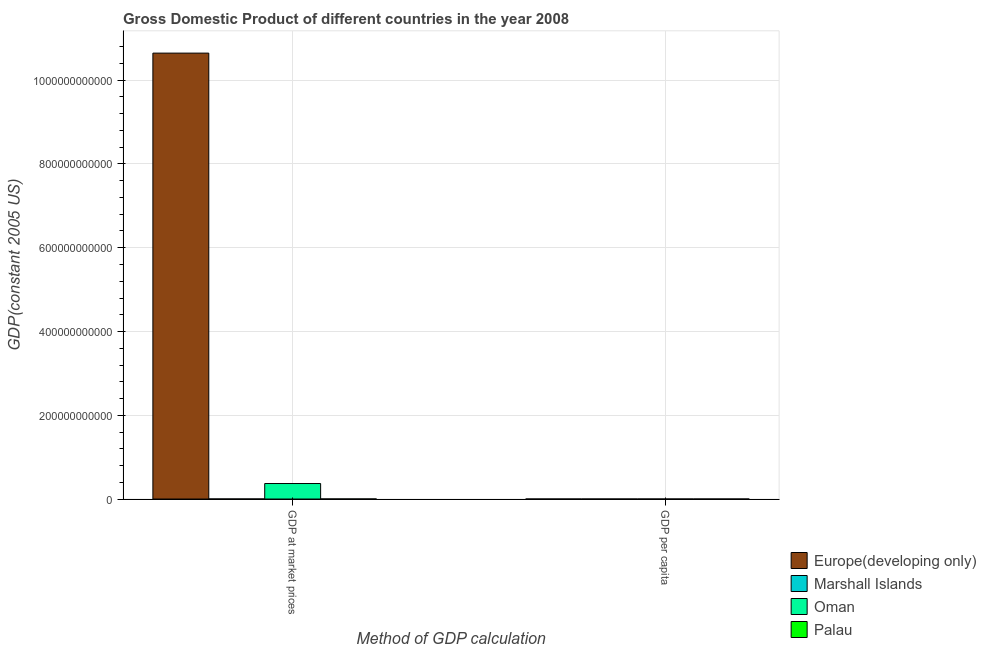How many groups of bars are there?
Provide a short and direct response. 2. Are the number of bars on each tick of the X-axis equal?
Your response must be concise. Yes. How many bars are there on the 1st tick from the left?
Provide a succinct answer. 4. How many bars are there on the 2nd tick from the right?
Your answer should be compact. 4. What is the label of the 1st group of bars from the left?
Provide a short and direct response. GDP at market prices. What is the gdp at market prices in Europe(developing only)?
Offer a terse response. 1.06e+12. Across all countries, what is the maximum gdp per capita?
Your answer should be compact. 1.40e+04. Across all countries, what is the minimum gdp per capita?
Your answer should be very brief. 2736.21. In which country was the gdp at market prices maximum?
Ensure brevity in your answer.  Europe(developing only). In which country was the gdp at market prices minimum?
Provide a short and direct response. Marshall Islands. What is the total gdp at market prices in the graph?
Give a very brief answer. 1.10e+12. What is the difference between the gdp per capita in Palau and that in Oman?
Your answer should be compact. -4999.17. What is the difference between the gdp per capita in Palau and the gdp at market prices in Oman?
Offer a terse response. -3.70e+1. What is the average gdp at market prices per country?
Provide a short and direct response. 2.76e+11. What is the difference between the gdp per capita and gdp at market prices in Palau?
Ensure brevity in your answer.  -1.81e+08. In how many countries, is the gdp per capita greater than 640000000000 US$?
Your answer should be compact. 0. What is the ratio of the gdp per capita in Europe(developing only) to that in Palau?
Offer a very short reply. 0.47. What does the 4th bar from the left in GDP at market prices represents?
Offer a very short reply. Palau. What does the 4th bar from the right in GDP per capita represents?
Make the answer very short. Europe(developing only). How many bars are there?
Give a very brief answer. 8. What is the difference between two consecutive major ticks on the Y-axis?
Provide a succinct answer. 2.00e+11. Does the graph contain any zero values?
Keep it short and to the point. No. Does the graph contain grids?
Ensure brevity in your answer.  Yes. How many legend labels are there?
Provide a short and direct response. 4. What is the title of the graph?
Keep it short and to the point. Gross Domestic Product of different countries in the year 2008. Does "Jordan" appear as one of the legend labels in the graph?
Give a very brief answer. No. What is the label or title of the X-axis?
Your response must be concise. Method of GDP calculation. What is the label or title of the Y-axis?
Give a very brief answer. GDP(constant 2005 US). What is the GDP(constant 2005 US) in Europe(developing only) in GDP at market prices?
Your answer should be compact. 1.06e+12. What is the GDP(constant 2005 US) in Marshall Islands in GDP at market prices?
Your answer should be compact. 1.43e+08. What is the GDP(constant 2005 US) in Oman in GDP at market prices?
Your response must be concise. 3.70e+1. What is the GDP(constant 2005 US) in Palau in GDP at market prices?
Your response must be concise. 1.81e+08. What is the GDP(constant 2005 US) in Europe(developing only) in GDP per capita?
Offer a very short reply. 4210.45. What is the GDP(constant 2005 US) of Marshall Islands in GDP per capita?
Give a very brief answer. 2736.21. What is the GDP(constant 2005 US) in Oman in GDP per capita?
Make the answer very short. 1.40e+04. What is the GDP(constant 2005 US) of Palau in GDP per capita?
Give a very brief answer. 8956.79. Across all Method of GDP calculation, what is the maximum GDP(constant 2005 US) of Europe(developing only)?
Ensure brevity in your answer.  1.06e+12. Across all Method of GDP calculation, what is the maximum GDP(constant 2005 US) of Marshall Islands?
Make the answer very short. 1.43e+08. Across all Method of GDP calculation, what is the maximum GDP(constant 2005 US) of Oman?
Your answer should be very brief. 3.70e+1. Across all Method of GDP calculation, what is the maximum GDP(constant 2005 US) of Palau?
Ensure brevity in your answer.  1.81e+08. Across all Method of GDP calculation, what is the minimum GDP(constant 2005 US) in Europe(developing only)?
Give a very brief answer. 4210.45. Across all Method of GDP calculation, what is the minimum GDP(constant 2005 US) of Marshall Islands?
Offer a very short reply. 2736.21. Across all Method of GDP calculation, what is the minimum GDP(constant 2005 US) of Oman?
Provide a short and direct response. 1.40e+04. Across all Method of GDP calculation, what is the minimum GDP(constant 2005 US) in Palau?
Your response must be concise. 8956.79. What is the total GDP(constant 2005 US) of Europe(developing only) in the graph?
Provide a succinct answer. 1.06e+12. What is the total GDP(constant 2005 US) in Marshall Islands in the graph?
Keep it short and to the point. 1.43e+08. What is the total GDP(constant 2005 US) of Oman in the graph?
Offer a very short reply. 3.70e+1. What is the total GDP(constant 2005 US) of Palau in the graph?
Offer a very short reply. 1.81e+08. What is the difference between the GDP(constant 2005 US) in Europe(developing only) in GDP at market prices and that in GDP per capita?
Give a very brief answer. 1.06e+12. What is the difference between the GDP(constant 2005 US) in Marshall Islands in GDP at market prices and that in GDP per capita?
Give a very brief answer. 1.43e+08. What is the difference between the GDP(constant 2005 US) in Oman in GDP at market prices and that in GDP per capita?
Provide a succinct answer. 3.70e+1. What is the difference between the GDP(constant 2005 US) in Palau in GDP at market prices and that in GDP per capita?
Your response must be concise. 1.81e+08. What is the difference between the GDP(constant 2005 US) in Europe(developing only) in GDP at market prices and the GDP(constant 2005 US) in Marshall Islands in GDP per capita?
Your response must be concise. 1.06e+12. What is the difference between the GDP(constant 2005 US) in Europe(developing only) in GDP at market prices and the GDP(constant 2005 US) in Oman in GDP per capita?
Your response must be concise. 1.06e+12. What is the difference between the GDP(constant 2005 US) in Europe(developing only) in GDP at market prices and the GDP(constant 2005 US) in Palau in GDP per capita?
Your answer should be very brief. 1.06e+12. What is the difference between the GDP(constant 2005 US) in Marshall Islands in GDP at market prices and the GDP(constant 2005 US) in Oman in GDP per capita?
Provide a short and direct response. 1.43e+08. What is the difference between the GDP(constant 2005 US) in Marshall Islands in GDP at market prices and the GDP(constant 2005 US) in Palau in GDP per capita?
Offer a very short reply. 1.43e+08. What is the difference between the GDP(constant 2005 US) in Oman in GDP at market prices and the GDP(constant 2005 US) in Palau in GDP per capita?
Ensure brevity in your answer.  3.70e+1. What is the average GDP(constant 2005 US) of Europe(developing only) per Method of GDP calculation?
Your answer should be compact. 5.32e+11. What is the average GDP(constant 2005 US) in Marshall Islands per Method of GDP calculation?
Your answer should be very brief. 7.14e+07. What is the average GDP(constant 2005 US) in Oman per Method of GDP calculation?
Keep it short and to the point. 1.85e+1. What is the average GDP(constant 2005 US) in Palau per Method of GDP calculation?
Your answer should be compact. 9.06e+07. What is the difference between the GDP(constant 2005 US) in Europe(developing only) and GDP(constant 2005 US) in Marshall Islands in GDP at market prices?
Give a very brief answer. 1.06e+12. What is the difference between the GDP(constant 2005 US) of Europe(developing only) and GDP(constant 2005 US) of Oman in GDP at market prices?
Ensure brevity in your answer.  1.03e+12. What is the difference between the GDP(constant 2005 US) in Europe(developing only) and GDP(constant 2005 US) in Palau in GDP at market prices?
Ensure brevity in your answer.  1.06e+12. What is the difference between the GDP(constant 2005 US) of Marshall Islands and GDP(constant 2005 US) of Oman in GDP at market prices?
Make the answer very short. -3.69e+1. What is the difference between the GDP(constant 2005 US) of Marshall Islands and GDP(constant 2005 US) of Palau in GDP at market prices?
Provide a succinct answer. -3.83e+07. What is the difference between the GDP(constant 2005 US) of Oman and GDP(constant 2005 US) of Palau in GDP at market prices?
Offer a very short reply. 3.68e+1. What is the difference between the GDP(constant 2005 US) of Europe(developing only) and GDP(constant 2005 US) of Marshall Islands in GDP per capita?
Provide a succinct answer. 1474.24. What is the difference between the GDP(constant 2005 US) of Europe(developing only) and GDP(constant 2005 US) of Oman in GDP per capita?
Provide a succinct answer. -9745.5. What is the difference between the GDP(constant 2005 US) in Europe(developing only) and GDP(constant 2005 US) in Palau in GDP per capita?
Your answer should be very brief. -4746.34. What is the difference between the GDP(constant 2005 US) of Marshall Islands and GDP(constant 2005 US) of Oman in GDP per capita?
Ensure brevity in your answer.  -1.12e+04. What is the difference between the GDP(constant 2005 US) in Marshall Islands and GDP(constant 2005 US) in Palau in GDP per capita?
Your answer should be very brief. -6220.58. What is the difference between the GDP(constant 2005 US) of Oman and GDP(constant 2005 US) of Palau in GDP per capita?
Ensure brevity in your answer.  4999.17. What is the ratio of the GDP(constant 2005 US) in Europe(developing only) in GDP at market prices to that in GDP per capita?
Your answer should be compact. 2.53e+08. What is the ratio of the GDP(constant 2005 US) of Marshall Islands in GDP at market prices to that in GDP per capita?
Your response must be concise. 5.22e+04. What is the ratio of the GDP(constant 2005 US) in Oman in GDP at market prices to that in GDP per capita?
Your answer should be very brief. 2.65e+06. What is the ratio of the GDP(constant 2005 US) in Palau in GDP at market prices to that in GDP per capita?
Provide a succinct answer. 2.02e+04. What is the difference between the highest and the second highest GDP(constant 2005 US) of Europe(developing only)?
Your answer should be compact. 1.06e+12. What is the difference between the highest and the second highest GDP(constant 2005 US) in Marshall Islands?
Offer a terse response. 1.43e+08. What is the difference between the highest and the second highest GDP(constant 2005 US) of Oman?
Provide a short and direct response. 3.70e+1. What is the difference between the highest and the second highest GDP(constant 2005 US) in Palau?
Offer a terse response. 1.81e+08. What is the difference between the highest and the lowest GDP(constant 2005 US) in Europe(developing only)?
Your response must be concise. 1.06e+12. What is the difference between the highest and the lowest GDP(constant 2005 US) in Marshall Islands?
Your answer should be compact. 1.43e+08. What is the difference between the highest and the lowest GDP(constant 2005 US) in Oman?
Provide a short and direct response. 3.70e+1. What is the difference between the highest and the lowest GDP(constant 2005 US) of Palau?
Your answer should be very brief. 1.81e+08. 